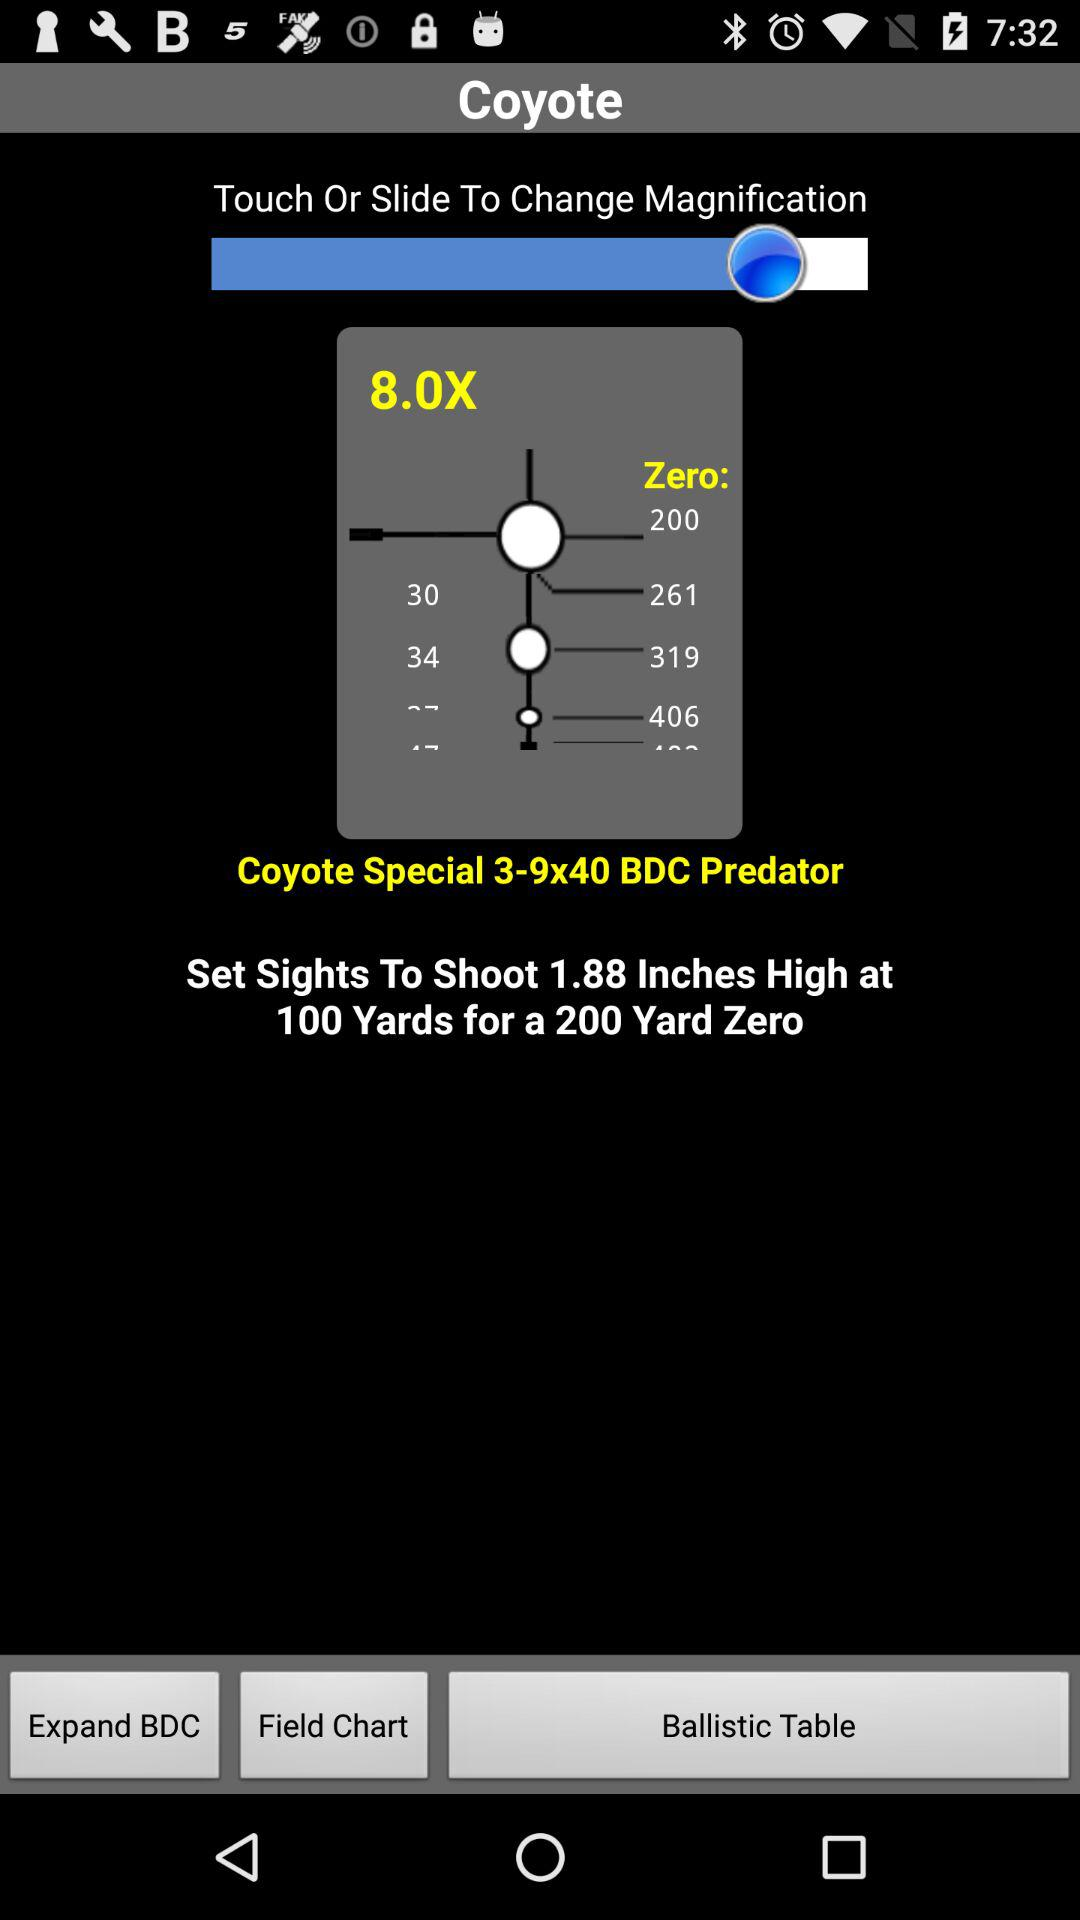What is the app name? The app name is "Coyote". 